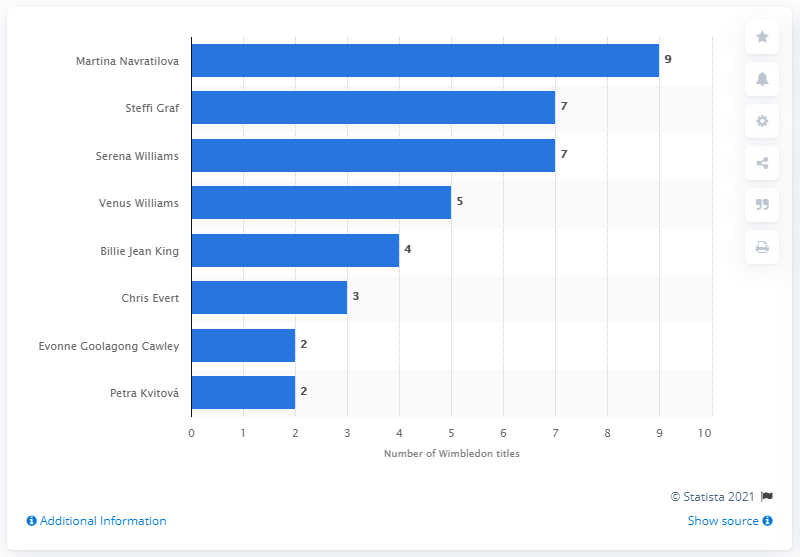Highlight a few significant elements in this photo. Steffi Graf, a tennis player, has won seven Wimbledon titles. 